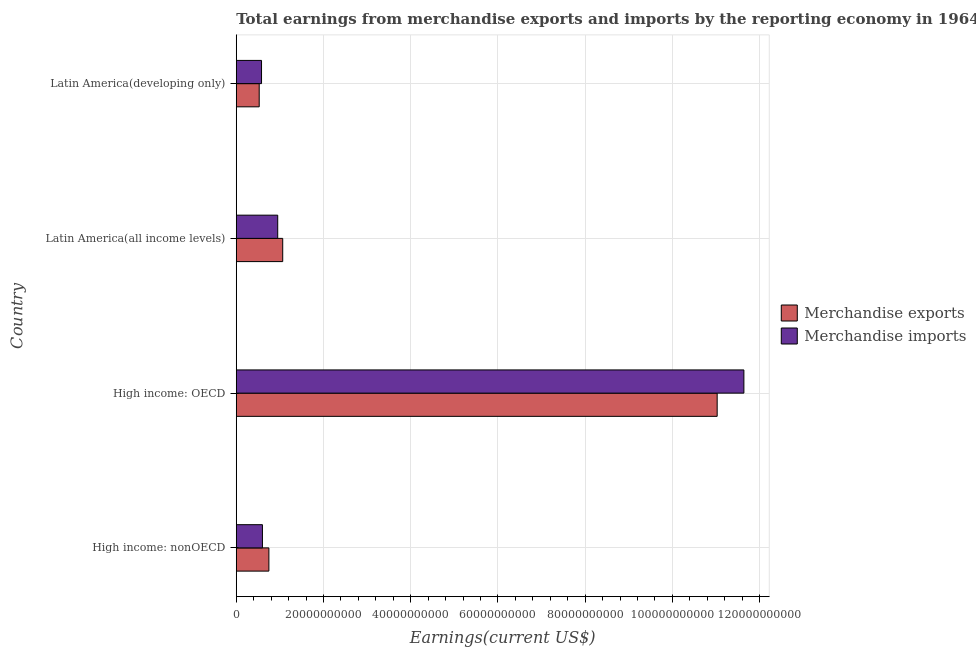How many different coloured bars are there?
Provide a succinct answer. 2. Are the number of bars on each tick of the Y-axis equal?
Your answer should be very brief. Yes. How many bars are there on the 2nd tick from the top?
Make the answer very short. 2. What is the label of the 3rd group of bars from the top?
Offer a terse response. High income: OECD. In how many cases, is the number of bars for a given country not equal to the number of legend labels?
Your response must be concise. 0. What is the earnings from merchandise imports in High income: OECD?
Provide a short and direct response. 1.16e+11. Across all countries, what is the maximum earnings from merchandise imports?
Provide a succinct answer. 1.16e+11. Across all countries, what is the minimum earnings from merchandise imports?
Offer a terse response. 5.80e+09. In which country was the earnings from merchandise imports maximum?
Offer a terse response. High income: OECD. In which country was the earnings from merchandise exports minimum?
Your answer should be compact. Latin America(developing only). What is the total earnings from merchandise exports in the graph?
Your answer should be compact. 1.34e+11. What is the difference between the earnings from merchandise imports in High income: nonOECD and that in Latin America(developing only)?
Offer a terse response. 2.08e+08. What is the difference between the earnings from merchandise exports in High income: nonOECD and the earnings from merchandise imports in Latin America(all income levels)?
Offer a very short reply. -2.03e+09. What is the average earnings from merchandise exports per country?
Ensure brevity in your answer.  3.34e+1. What is the difference between the earnings from merchandise exports and earnings from merchandise imports in Latin America(developing only)?
Your response must be concise. -5.34e+08. What is the ratio of the earnings from merchandise imports in High income: nonOECD to that in Latin America(all income levels)?
Provide a succinct answer. 0.63. Is the earnings from merchandise exports in High income: nonOECD less than that in Latin America(developing only)?
Give a very brief answer. No. Is the difference between the earnings from merchandise imports in High income: nonOECD and Latin America(developing only) greater than the difference between the earnings from merchandise exports in High income: nonOECD and Latin America(developing only)?
Your answer should be compact. No. What is the difference between the highest and the second highest earnings from merchandise exports?
Your answer should be very brief. 9.96e+1. What is the difference between the highest and the lowest earnings from merchandise exports?
Make the answer very short. 1.05e+11. In how many countries, is the earnings from merchandise exports greater than the average earnings from merchandise exports taken over all countries?
Your response must be concise. 1. Is the sum of the earnings from merchandise imports in High income: nonOECD and Latin America(developing only) greater than the maximum earnings from merchandise exports across all countries?
Offer a terse response. No. What does the 2nd bar from the top in Latin America(developing only) represents?
Your response must be concise. Merchandise exports. How many bars are there?
Your answer should be compact. 8. Are all the bars in the graph horizontal?
Ensure brevity in your answer.  Yes. Are the values on the major ticks of X-axis written in scientific E-notation?
Make the answer very short. No. Does the graph contain grids?
Offer a very short reply. Yes. How many legend labels are there?
Make the answer very short. 2. How are the legend labels stacked?
Give a very brief answer. Vertical. What is the title of the graph?
Make the answer very short. Total earnings from merchandise exports and imports by the reporting economy in 1964. Does "2012 US$" appear as one of the legend labels in the graph?
Offer a terse response. No. What is the label or title of the X-axis?
Your response must be concise. Earnings(current US$). What is the Earnings(current US$) in Merchandise exports in High income: nonOECD?
Provide a short and direct response. 7.48e+09. What is the Earnings(current US$) in Merchandise imports in High income: nonOECD?
Provide a succinct answer. 6.00e+09. What is the Earnings(current US$) in Merchandise exports in High income: OECD?
Your response must be concise. 1.10e+11. What is the Earnings(current US$) of Merchandise imports in High income: OECD?
Provide a short and direct response. 1.16e+11. What is the Earnings(current US$) in Merchandise exports in Latin America(all income levels)?
Provide a short and direct response. 1.07e+1. What is the Earnings(current US$) in Merchandise imports in Latin America(all income levels)?
Your answer should be compact. 9.51e+09. What is the Earnings(current US$) of Merchandise exports in Latin America(developing only)?
Provide a succinct answer. 5.26e+09. What is the Earnings(current US$) of Merchandise imports in Latin America(developing only)?
Your answer should be very brief. 5.80e+09. Across all countries, what is the maximum Earnings(current US$) of Merchandise exports?
Provide a succinct answer. 1.10e+11. Across all countries, what is the maximum Earnings(current US$) in Merchandise imports?
Offer a very short reply. 1.16e+11. Across all countries, what is the minimum Earnings(current US$) of Merchandise exports?
Provide a short and direct response. 5.26e+09. Across all countries, what is the minimum Earnings(current US$) in Merchandise imports?
Keep it short and to the point. 5.80e+09. What is the total Earnings(current US$) in Merchandise exports in the graph?
Provide a short and direct response. 1.34e+11. What is the total Earnings(current US$) of Merchandise imports in the graph?
Offer a terse response. 1.38e+11. What is the difference between the Earnings(current US$) of Merchandise exports in High income: nonOECD and that in High income: OECD?
Keep it short and to the point. -1.03e+11. What is the difference between the Earnings(current US$) in Merchandise imports in High income: nonOECD and that in High income: OECD?
Ensure brevity in your answer.  -1.10e+11. What is the difference between the Earnings(current US$) in Merchandise exports in High income: nonOECD and that in Latin America(all income levels)?
Make the answer very short. -3.17e+09. What is the difference between the Earnings(current US$) in Merchandise imports in High income: nonOECD and that in Latin America(all income levels)?
Offer a very short reply. -3.50e+09. What is the difference between the Earnings(current US$) in Merchandise exports in High income: nonOECD and that in Latin America(developing only)?
Offer a terse response. 2.22e+09. What is the difference between the Earnings(current US$) of Merchandise imports in High income: nonOECD and that in Latin America(developing only)?
Your response must be concise. 2.08e+08. What is the difference between the Earnings(current US$) in Merchandise exports in High income: OECD and that in Latin America(all income levels)?
Offer a terse response. 9.96e+1. What is the difference between the Earnings(current US$) of Merchandise imports in High income: OECD and that in Latin America(all income levels)?
Give a very brief answer. 1.07e+11. What is the difference between the Earnings(current US$) in Merchandise exports in High income: OECD and that in Latin America(developing only)?
Provide a short and direct response. 1.05e+11. What is the difference between the Earnings(current US$) in Merchandise imports in High income: OECD and that in Latin America(developing only)?
Provide a succinct answer. 1.11e+11. What is the difference between the Earnings(current US$) of Merchandise exports in Latin America(all income levels) and that in Latin America(developing only)?
Offer a very short reply. 5.39e+09. What is the difference between the Earnings(current US$) of Merchandise imports in Latin America(all income levels) and that in Latin America(developing only)?
Provide a short and direct response. 3.71e+09. What is the difference between the Earnings(current US$) of Merchandise exports in High income: nonOECD and the Earnings(current US$) of Merchandise imports in High income: OECD?
Provide a succinct answer. -1.09e+11. What is the difference between the Earnings(current US$) in Merchandise exports in High income: nonOECD and the Earnings(current US$) in Merchandise imports in Latin America(all income levels)?
Offer a terse response. -2.03e+09. What is the difference between the Earnings(current US$) in Merchandise exports in High income: nonOECD and the Earnings(current US$) in Merchandise imports in Latin America(developing only)?
Your answer should be very brief. 1.69e+09. What is the difference between the Earnings(current US$) in Merchandise exports in High income: OECD and the Earnings(current US$) in Merchandise imports in Latin America(all income levels)?
Provide a succinct answer. 1.01e+11. What is the difference between the Earnings(current US$) of Merchandise exports in High income: OECD and the Earnings(current US$) of Merchandise imports in Latin America(developing only)?
Make the answer very short. 1.04e+11. What is the difference between the Earnings(current US$) in Merchandise exports in Latin America(all income levels) and the Earnings(current US$) in Merchandise imports in Latin America(developing only)?
Provide a succinct answer. 4.86e+09. What is the average Earnings(current US$) of Merchandise exports per country?
Your answer should be very brief. 3.34e+1. What is the average Earnings(current US$) in Merchandise imports per country?
Your answer should be very brief. 3.44e+1. What is the difference between the Earnings(current US$) of Merchandise exports and Earnings(current US$) of Merchandise imports in High income: nonOECD?
Your answer should be very brief. 1.48e+09. What is the difference between the Earnings(current US$) in Merchandise exports and Earnings(current US$) in Merchandise imports in High income: OECD?
Keep it short and to the point. -6.13e+09. What is the difference between the Earnings(current US$) of Merchandise exports and Earnings(current US$) of Merchandise imports in Latin America(all income levels)?
Your answer should be very brief. 1.15e+09. What is the difference between the Earnings(current US$) in Merchandise exports and Earnings(current US$) in Merchandise imports in Latin America(developing only)?
Your response must be concise. -5.34e+08. What is the ratio of the Earnings(current US$) in Merchandise exports in High income: nonOECD to that in High income: OECD?
Give a very brief answer. 0.07. What is the ratio of the Earnings(current US$) of Merchandise imports in High income: nonOECD to that in High income: OECD?
Make the answer very short. 0.05. What is the ratio of the Earnings(current US$) in Merchandise exports in High income: nonOECD to that in Latin America(all income levels)?
Offer a terse response. 0.7. What is the ratio of the Earnings(current US$) in Merchandise imports in High income: nonOECD to that in Latin America(all income levels)?
Provide a short and direct response. 0.63. What is the ratio of the Earnings(current US$) of Merchandise exports in High income: nonOECD to that in Latin America(developing only)?
Your answer should be very brief. 1.42. What is the ratio of the Earnings(current US$) in Merchandise imports in High income: nonOECD to that in Latin America(developing only)?
Keep it short and to the point. 1.04. What is the ratio of the Earnings(current US$) of Merchandise exports in High income: OECD to that in Latin America(all income levels)?
Offer a terse response. 10.35. What is the ratio of the Earnings(current US$) in Merchandise imports in High income: OECD to that in Latin America(all income levels)?
Give a very brief answer. 12.24. What is the ratio of the Earnings(current US$) in Merchandise exports in High income: OECD to that in Latin America(developing only)?
Your answer should be very brief. 20.95. What is the ratio of the Earnings(current US$) of Merchandise imports in High income: OECD to that in Latin America(developing only)?
Make the answer very short. 20.08. What is the ratio of the Earnings(current US$) of Merchandise exports in Latin America(all income levels) to that in Latin America(developing only)?
Provide a succinct answer. 2.02. What is the ratio of the Earnings(current US$) of Merchandise imports in Latin America(all income levels) to that in Latin America(developing only)?
Offer a terse response. 1.64. What is the difference between the highest and the second highest Earnings(current US$) of Merchandise exports?
Provide a short and direct response. 9.96e+1. What is the difference between the highest and the second highest Earnings(current US$) of Merchandise imports?
Make the answer very short. 1.07e+11. What is the difference between the highest and the lowest Earnings(current US$) of Merchandise exports?
Provide a short and direct response. 1.05e+11. What is the difference between the highest and the lowest Earnings(current US$) in Merchandise imports?
Make the answer very short. 1.11e+11. 